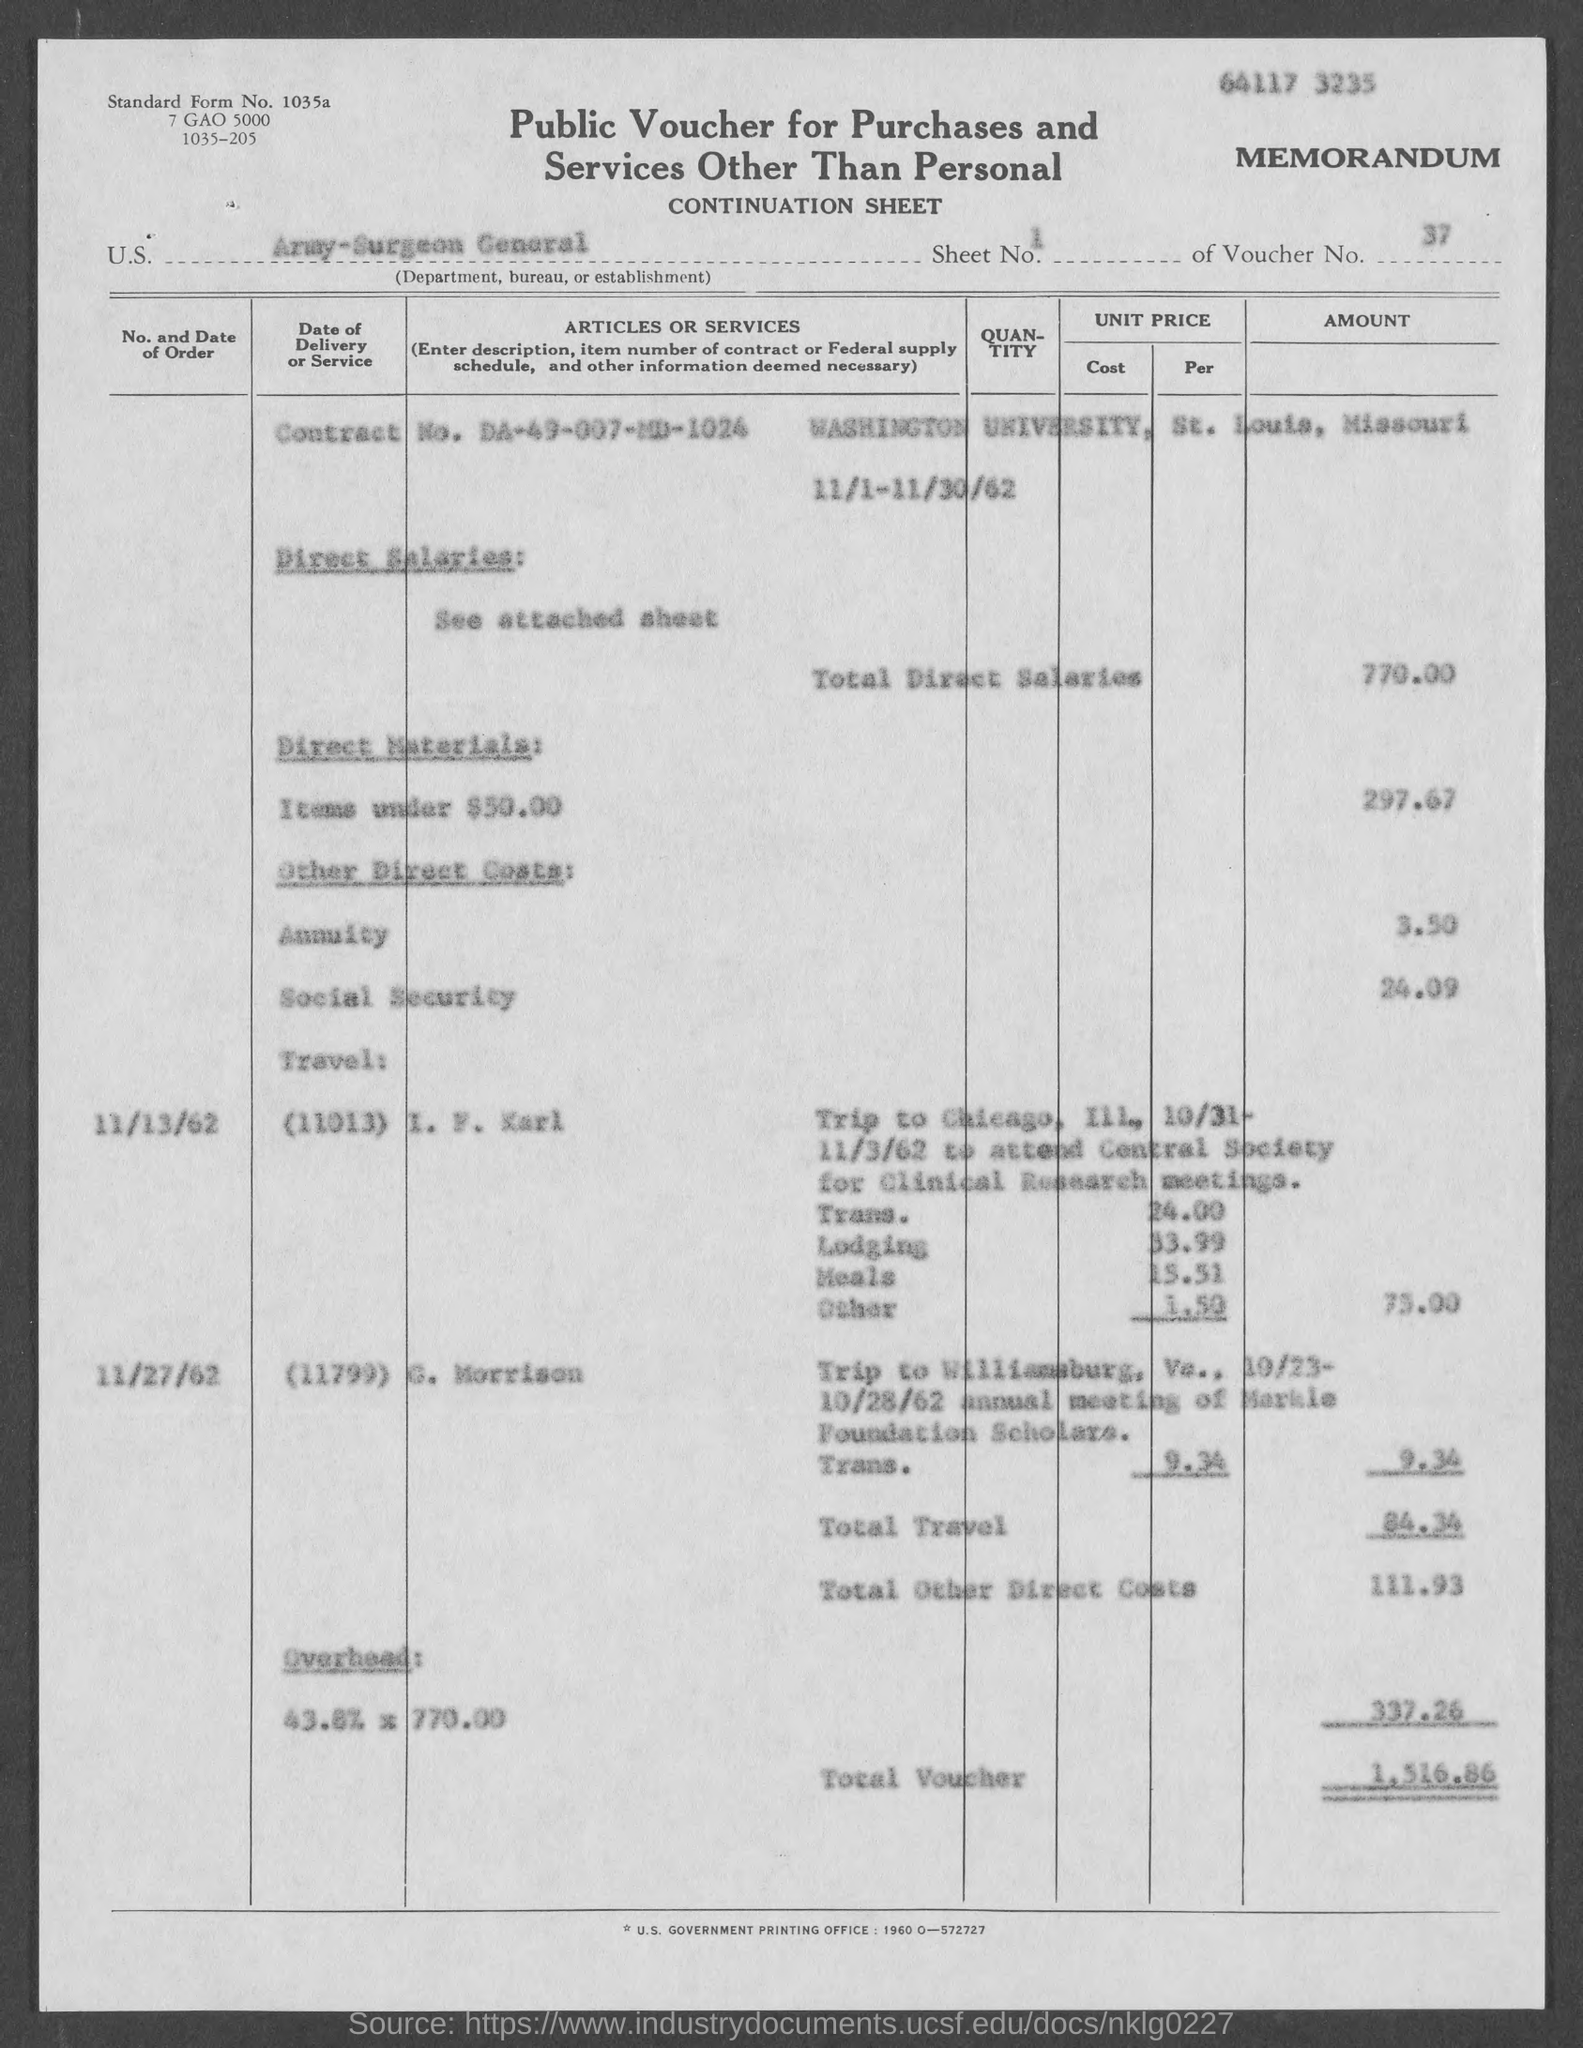what is the amount for overhead mentioned in the given form ? The form lists the overhead amount as $337.26, which is calculated based on the total direct salaries of $770.00. 